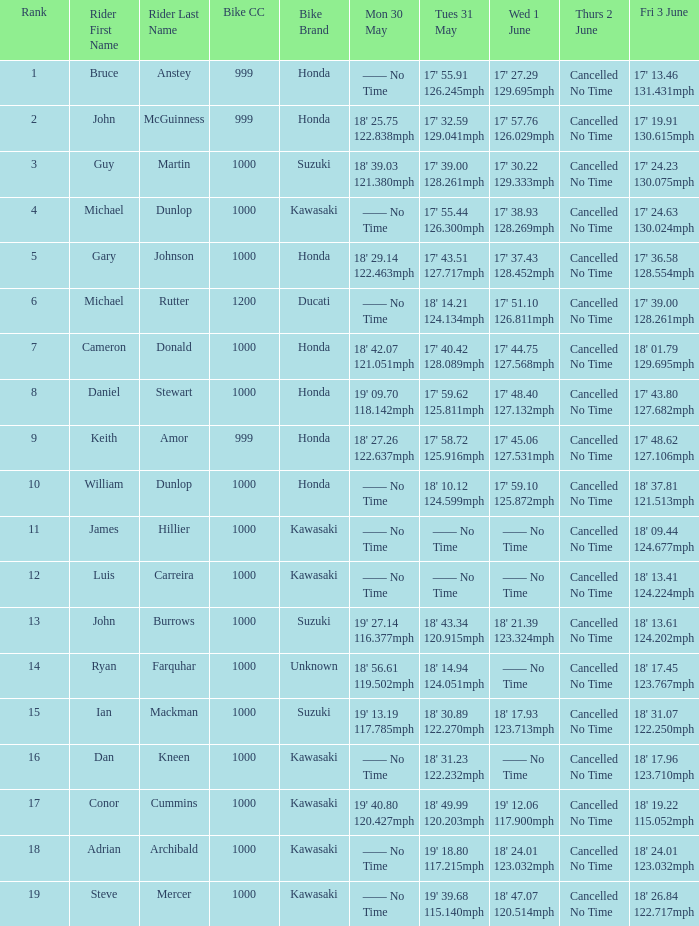What is the Mon 30 May time for the rider whose Fri 3 June time was 17' 13.46 131.431mph? —— No Time. 